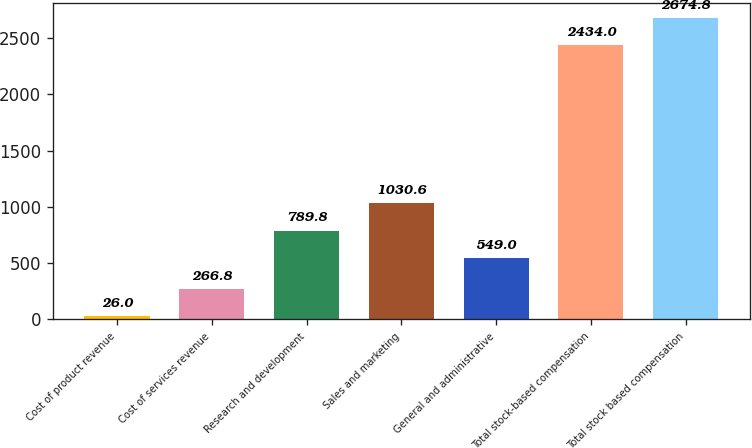<chart> <loc_0><loc_0><loc_500><loc_500><bar_chart><fcel>Cost of product revenue<fcel>Cost of services revenue<fcel>Research and development<fcel>Sales and marketing<fcel>General and administrative<fcel>Total stock-based compensation<fcel>Total stock based compensation<nl><fcel>26<fcel>266.8<fcel>789.8<fcel>1030.6<fcel>549<fcel>2434<fcel>2674.8<nl></chart> 